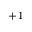<formula> <loc_0><loc_0><loc_500><loc_500>+ 1</formula> 